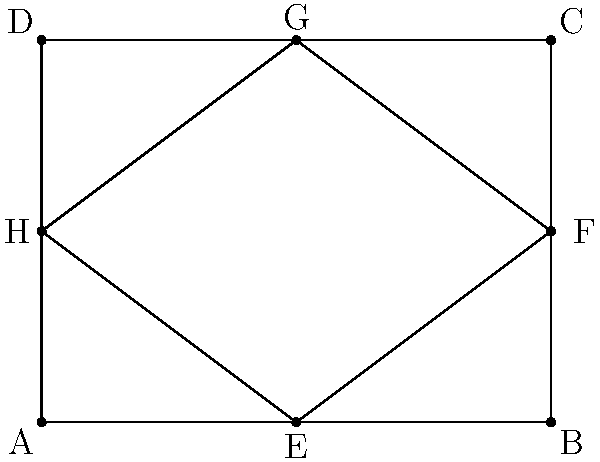While cataloging the floor plans of the millionaire's mansion, you come across a unique room design. The room is rectangular with dimensions 4 units by 3 units, as shown in the diagram. Inside this room, there's a smaller rectangular area EFGH. If triangle AEH is congruent to triangle BGF, what is the area of the inner rectangle EFGH? Let's approach this step-by-step:

1) First, we need to recognize that if triangle AEH is congruent to triangle BGF, then AE = BG, EH = GF, and AH = BF.

2) We know that AB = 4 units (the length of the room). If AE = BG, then E and G must be midpoints of AB and DC respectively. So, AE = EB = 2 units.

3) The height of the room (AD) is 3 units. If AH = BF, then H and F must be midpoints of AD and BC respectively. So, AH = HD = 1.5 units.

4) Now we have the dimensions of the inner rectangle EFGH:
   - Width: EF = AB - (AE + BG) = 4 - (2 + 2) = 0 units
   - Height: EH = AD - (AH + HD) = 3 - (1.5 + 1.5) = 0 units

5) The area of a rectangle is given by the formula: $A = l * w$, where $l$ is length and $w$ is width.

6) Therefore, the area of rectangle EFGH is:
   $A = 0 * 0 = 0$ square units

The inner rectangle has collapsed into a single point, which has no area.
Answer: 0 square units 